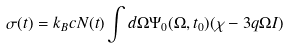Convert formula to latex. <formula><loc_0><loc_0><loc_500><loc_500>\sigma ( t ) = k _ { B } c N ( t ) \int d \Omega \Psi _ { 0 } ( \Omega , t _ { 0 } ) ( \chi - 3 q \Omega I )</formula> 